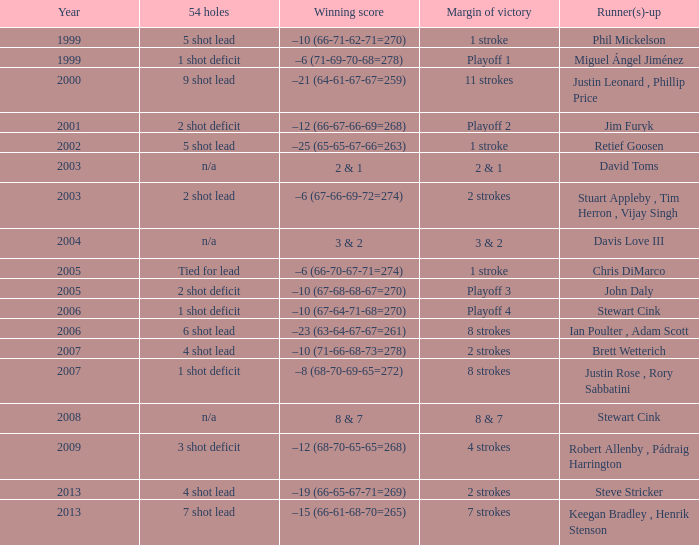In which year is the highest for runner-up Steve Stricker? 2013.0. 